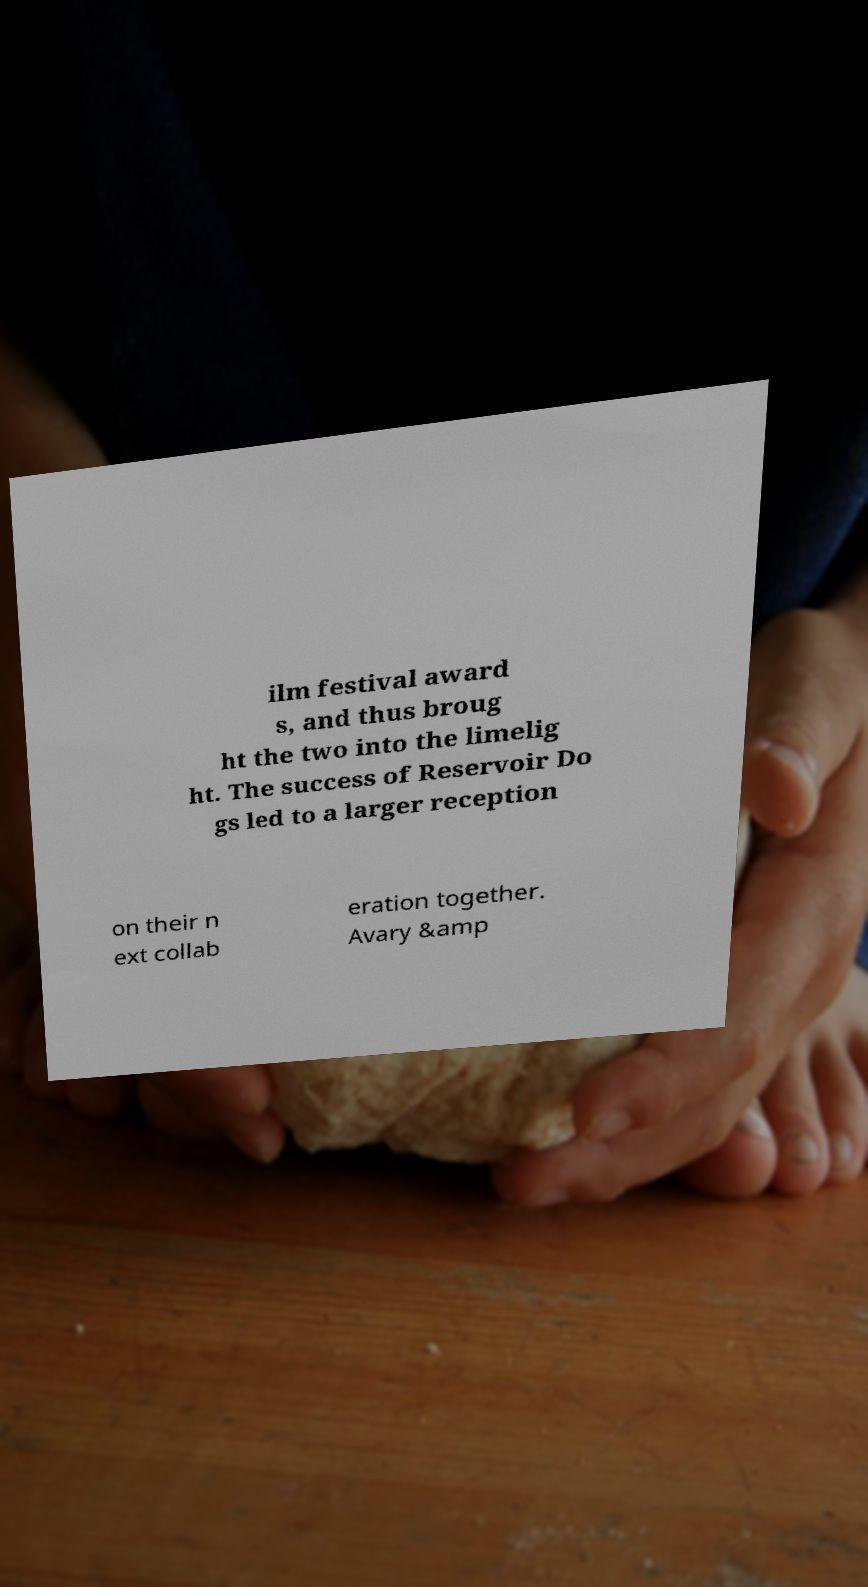Can you read and provide the text displayed in the image?This photo seems to have some interesting text. Can you extract and type it out for me? ilm festival award s, and thus broug ht the two into the limelig ht. The success of Reservoir Do gs led to a larger reception on their n ext collab eration together. Avary &amp 